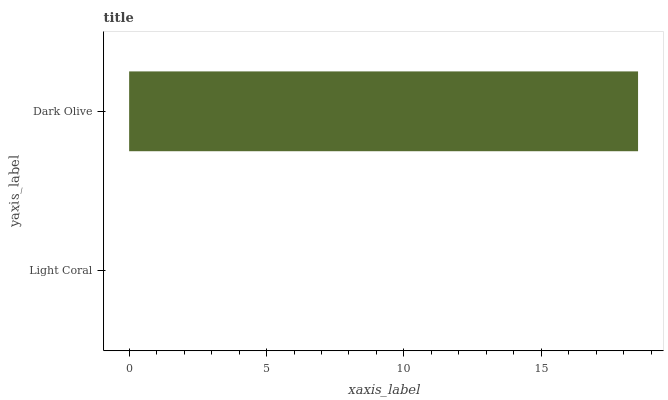Is Light Coral the minimum?
Answer yes or no. Yes. Is Dark Olive the maximum?
Answer yes or no. Yes. Is Dark Olive the minimum?
Answer yes or no. No. Is Dark Olive greater than Light Coral?
Answer yes or no. Yes. Is Light Coral less than Dark Olive?
Answer yes or no. Yes. Is Light Coral greater than Dark Olive?
Answer yes or no. No. Is Dark Olive less than Light Coral?
Answer yes or no. No. Is Dark Olive the high median?
Answer yes or no. Yes. Is Light Coral the low median?
Answer yes or no. Yes. Is Light Coral the high median?
Answer yes or no. No. Is Dark Olive the low median?
Answer yes or no. No. 